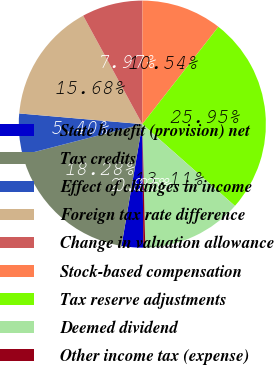Convert chart. <chart><loc_0><loc_0><loc_500><loc_500><pie_chart><fcel>State benefit (provision) net<fcel>Tax credits<fcel>Effect of changes in income<fcel>Foreign tax rate difference<fcel>Change in valuation allowance<fcel>Stock-based compensation<fcel>Tax reserve adjustments<fcel>Deemed dividend<fcel>Other income tax (expense)<nl><fcel>2.83%<fcel>18.29%<fcel>5.4%<fcel>15.68%<fcel>7.97%<fcel>10.54%<fcel>25.96%<fcel>13.11%<fcel>0.25%<nl></chart> 